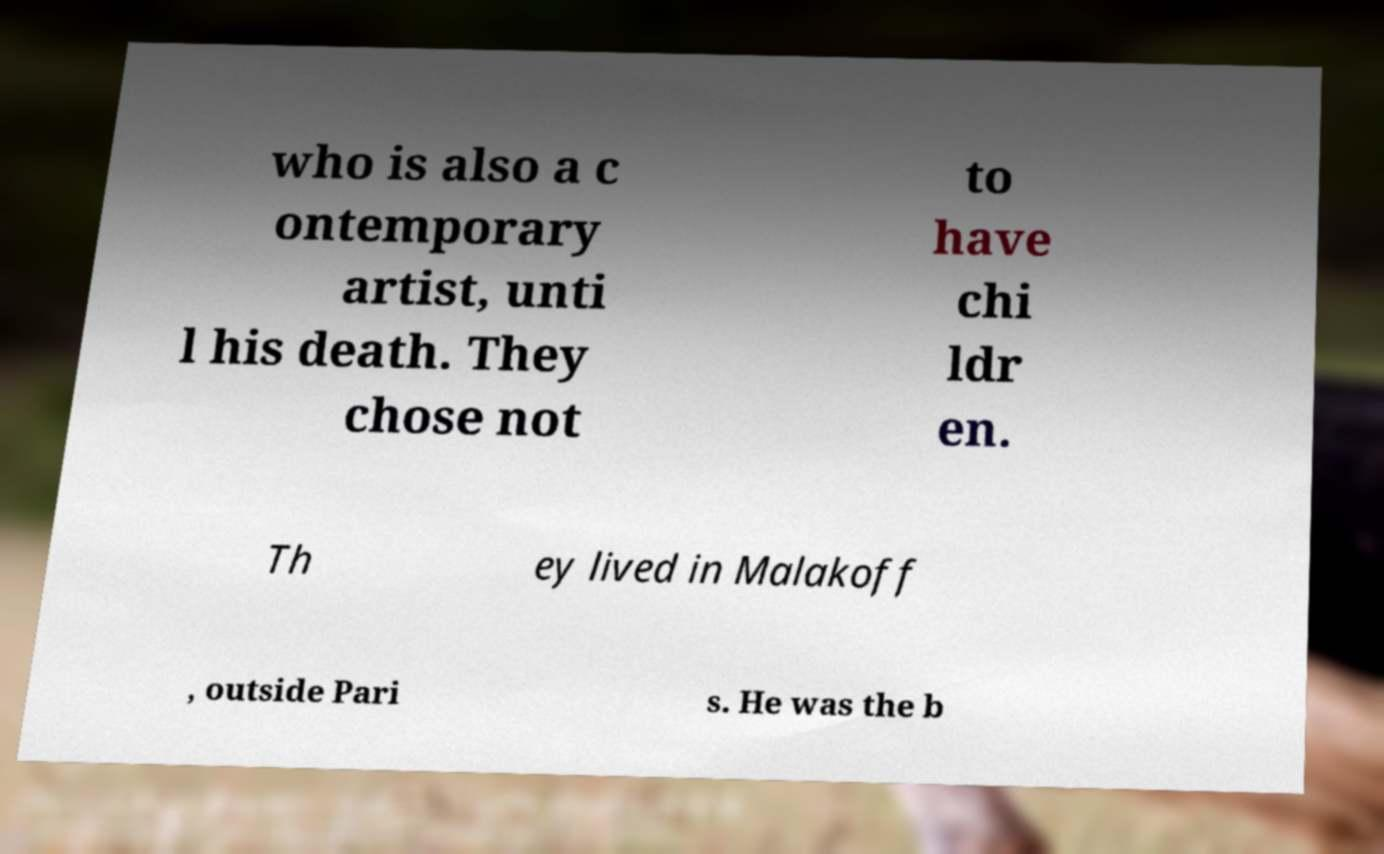I need the written content from this picture converted into text. Can you do that? who is also a c ontemporary artist, unti l his death. They chose not to have chi ldr en. Th ey lived in Malakoff , outside Pari s. He was the b 